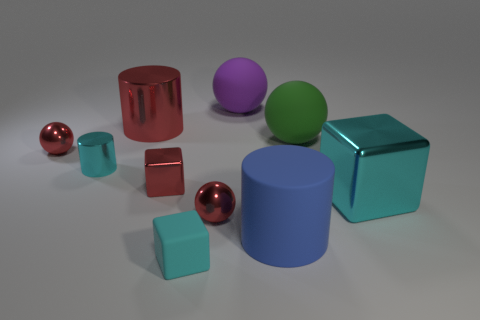How many metallic spheres are in front of the big cyan metallic block? There is just one metallic sphere placed in front of the big cyan metallic block, which is the red sphere slightly to the left. 